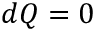<formula> <loc_0><loc_0><loc_500><loc_500>d Q = 0</formula> 